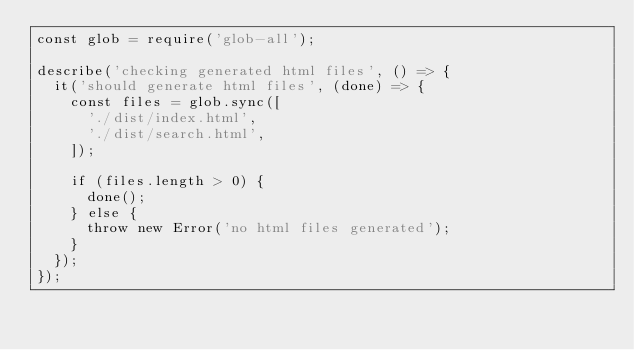Convert code to text. <code><loc_0><loc_0><loc_500><loc_500><_JavaScript_>const glob = require('glob-all');

describe('checking generated html files', () => {
  it('should generate html files', (done) => {
    const files = glob.sync([
      './dist/index.html',
      './dist/search.html',
    ]);

    if (files.length > 0) {
      done();
    } else {
      throw new Error('no html files generated');
    }
  });
});
</code> 